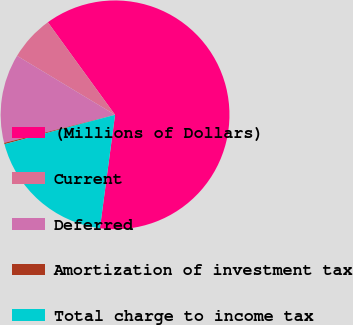<chart> <loc_0><loc_0><loc_500><loc_500><pie_chart><fcel>(Millions of Dollars)<fcel>Current<fcel>Deferred<fcel>Amortization of investment tax<fcel>Total charge to income tax<nl><fcel>62.11%<fcel>6.38%<fcel>12.57%<fcel>0.19%<fcel>18.76%<nl></chart> 